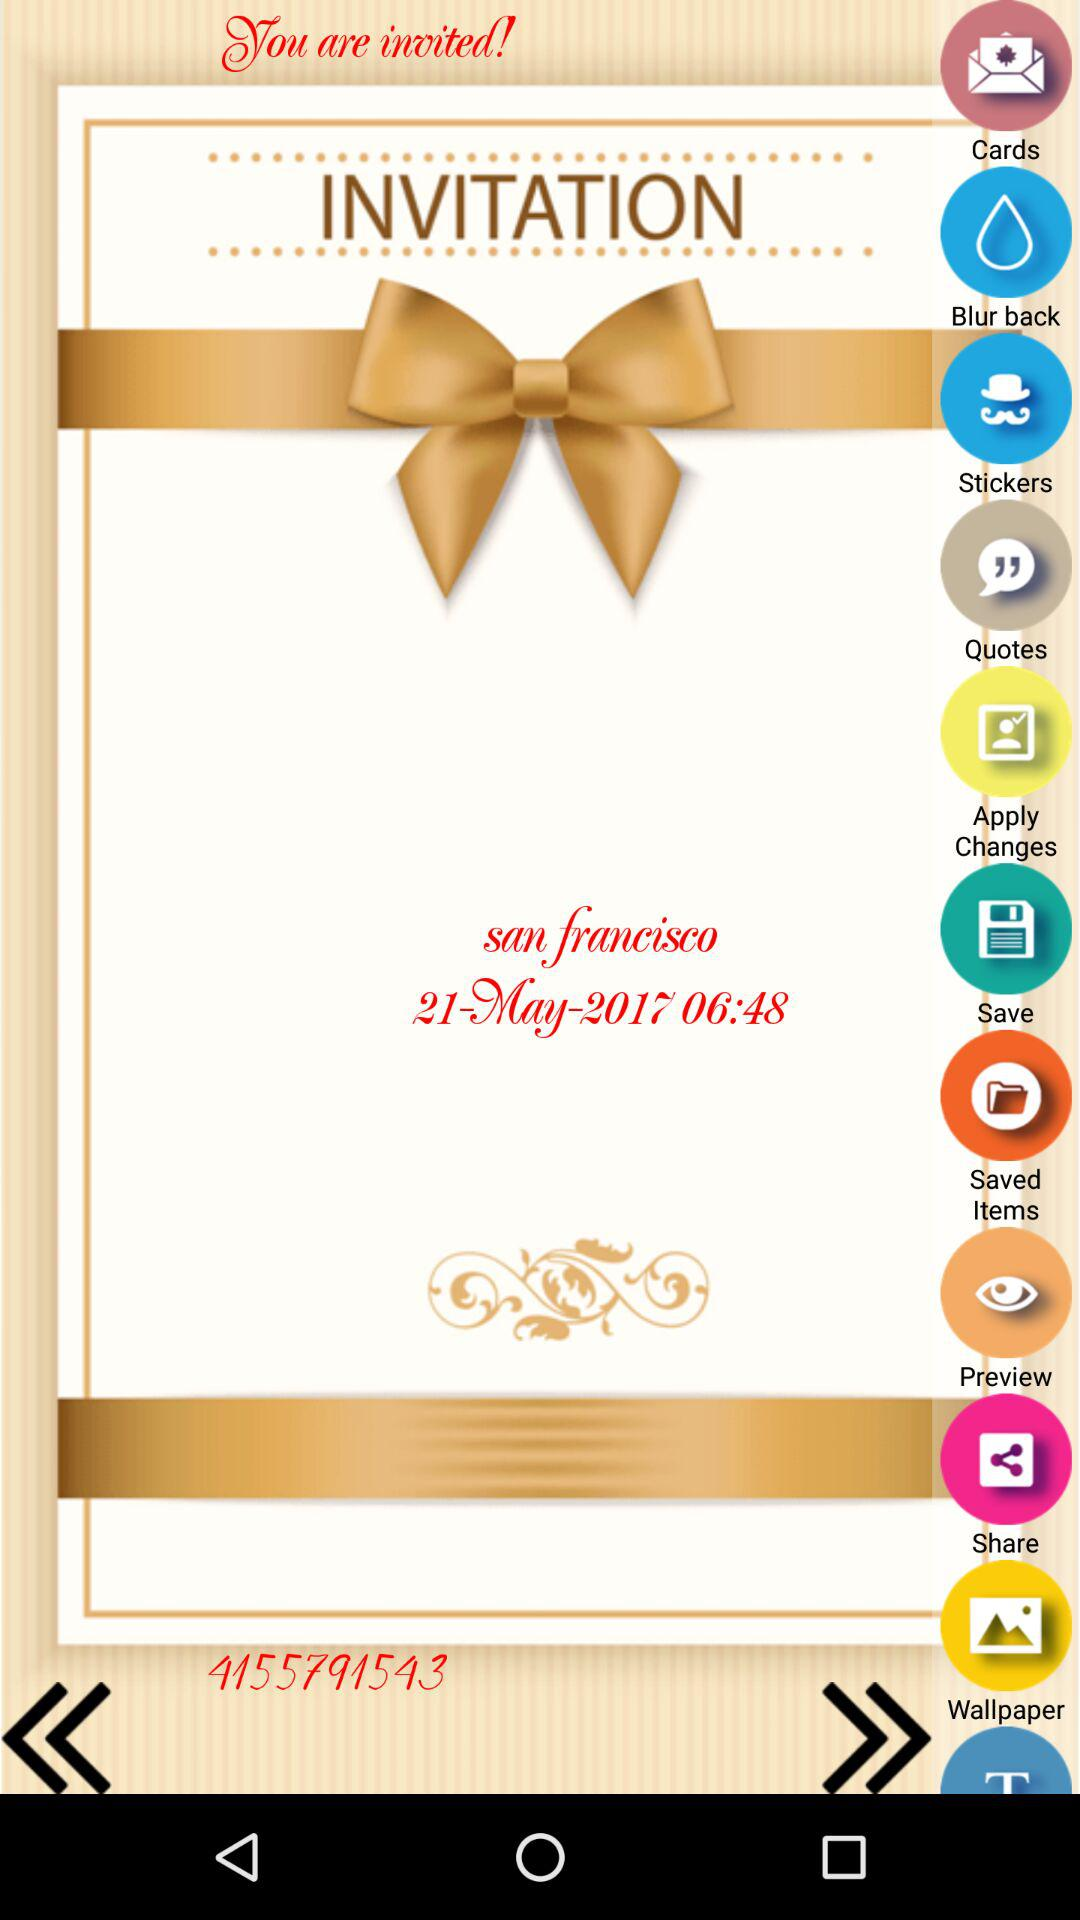At what place is the event scheduled? The place is "san francisco". 